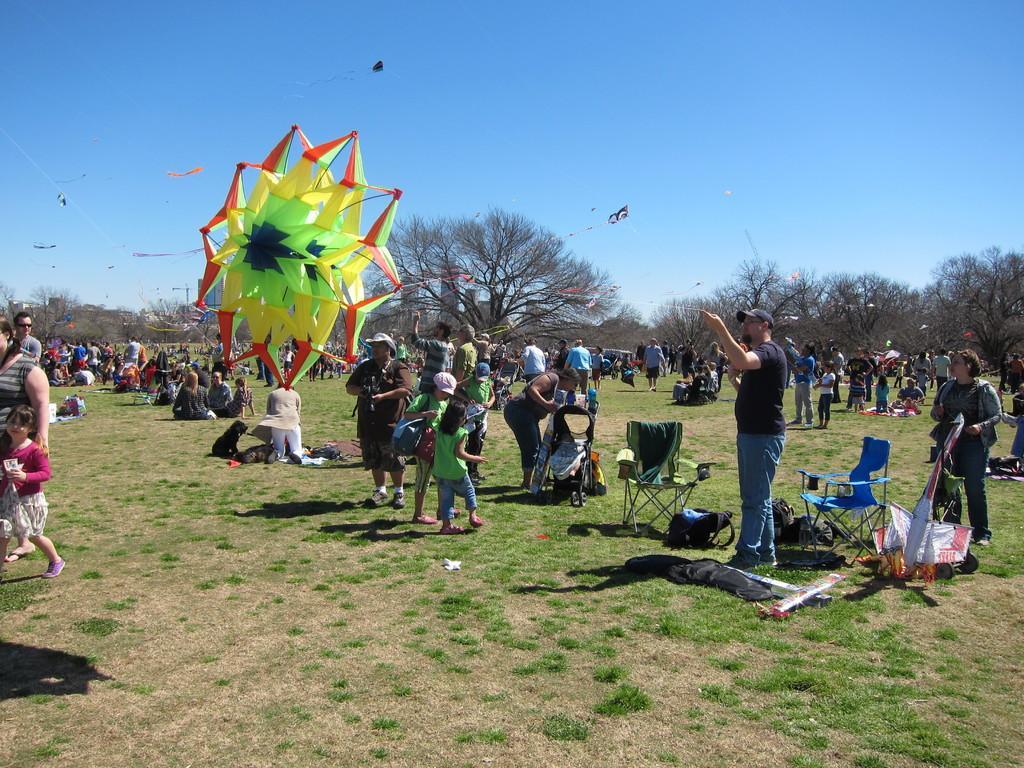How would you summarize this image in a sentence or two? Sky is in blue color. Here we can see kites, people, chairs and objects. Far there are trees. Land is covered with grass. 